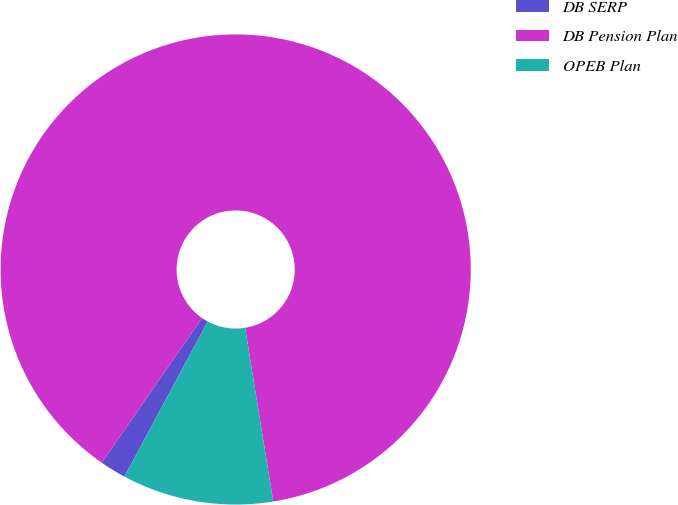<chart> <loc_0><loc_0><loc_500><loc_500><pie_chart><fcel>DB SERP<fcel>DB Pension Plan<fcel>OPEB Plan<nl><fcel>1.8%<fcel>87.8%<fcel>10.4%<nl></chart> 